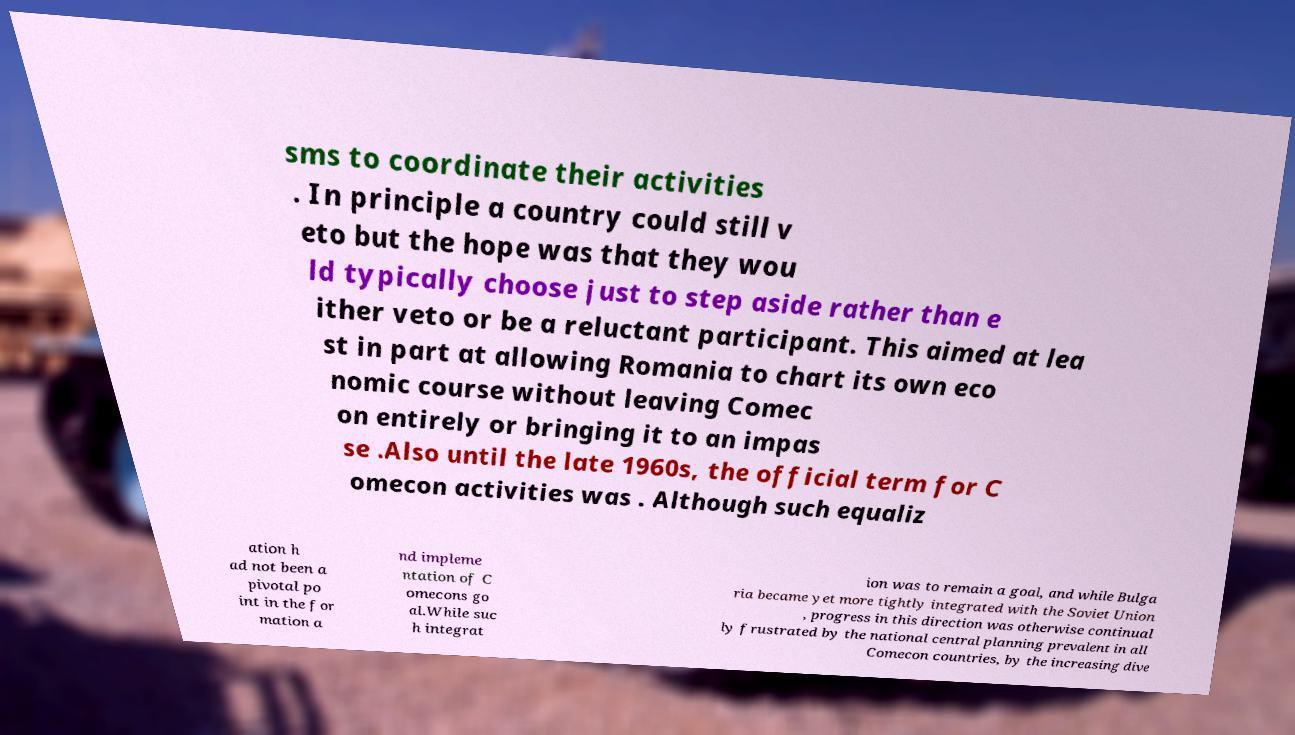Please identify and transcribe the text found in this image. sms to coordinate their activities . In principle a country could still v eto but the hope was that they wou ld typically choose just to step aside rather than e ither veto or be a reluctant participant. This aimed at lea st in part at allowing Romania to chart its own eco nomic course without leaving Comec on entirely or bringing it to an impas se .Also until the late 1960s, the official term for C omecon activities was . Although such equaliz ation h ad not been a pivotal po int in the for mation a nd impleme ntation of C omecons go al.While suc h integrat ion was to remain a goal, and while Bulga ria became yet more tightly integrated with the Soviet Union , progress in this direction was otherwise continual ly frustrated by the national central planning prevalent in all Comecon countries, by the increasing dive 